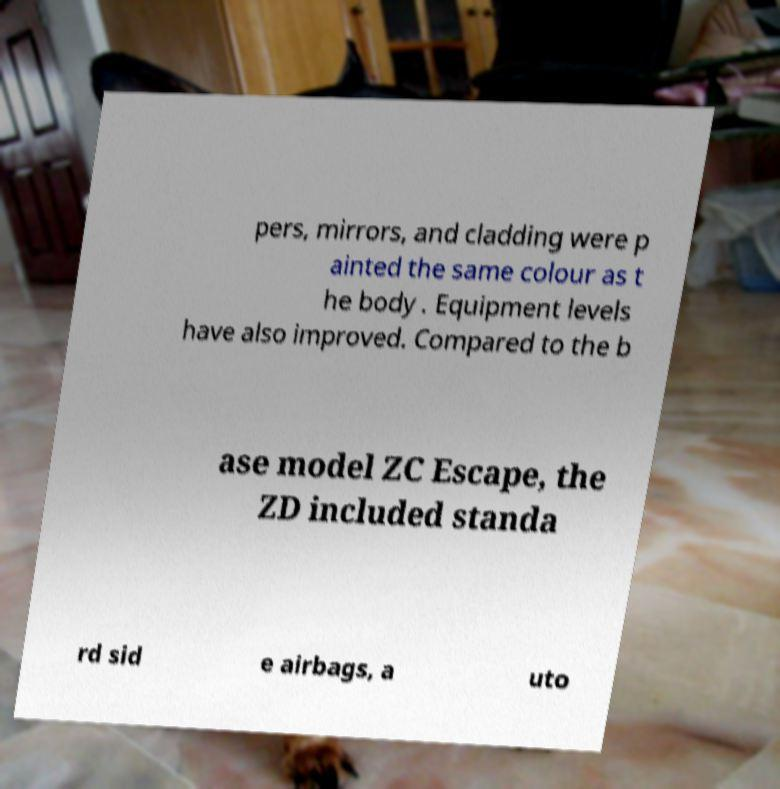Can you accurately transcribe the text from the provided image for me? pers, mirrors, and cladding were p ainted the same colour as t he body . Equipment levels have also improved. Compared to the b ase model ZC Escape, the ZD included standa rd sid e airbags, a uto 